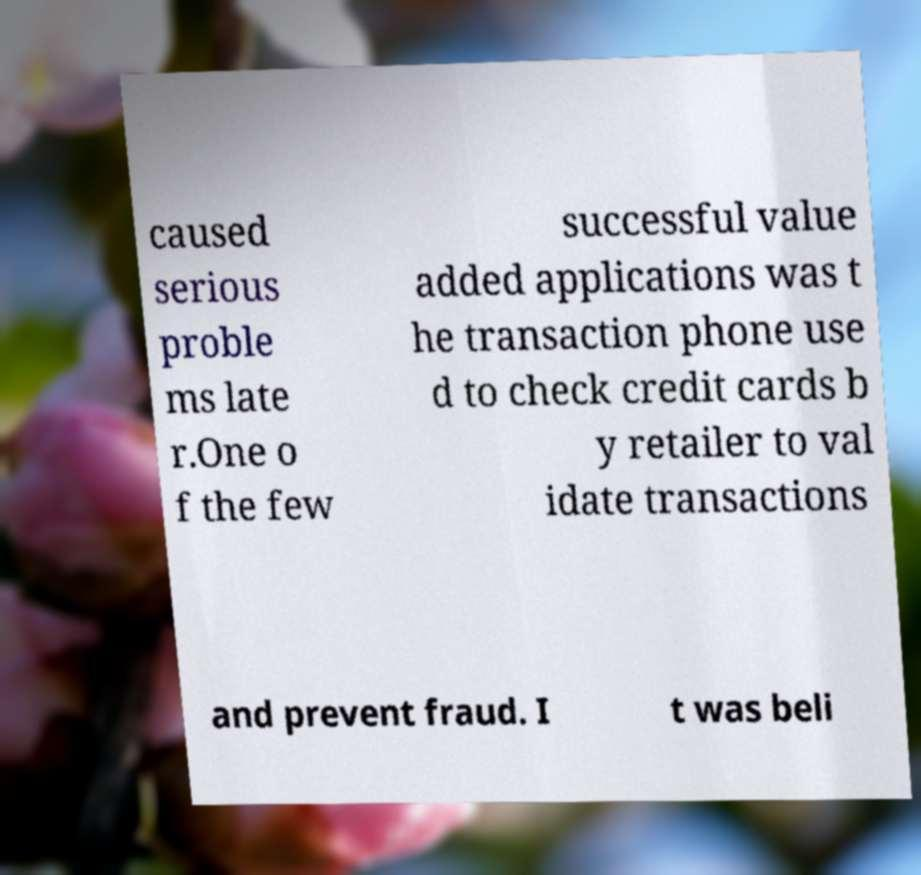Can you read and provide the text displayed in the image?This photo seems to have some interesting text. Can you extract and type it out for me? caused serious proble ms late r.One o f the few successful value added applications was t he transaction phone use d to check credit cards b y retailer to val idate transactions and prevent fraud. I t was beli 